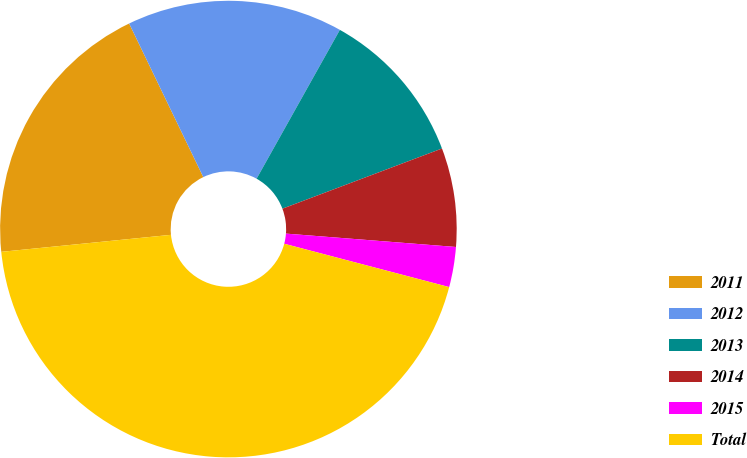Convert chart. <chart><loc_0><loc_0><loc_500><loc_500><pie_chart><fcel>2011<fcel>2012<fcel>2013<fcel>2014<fcel>2015<fcel>Total<nl><fcel>19.43%<fcel>15.28%<fcel>11.14%<fcel>6.99%<fcel>2.84%<fcel>44.32%<nl></chart> 